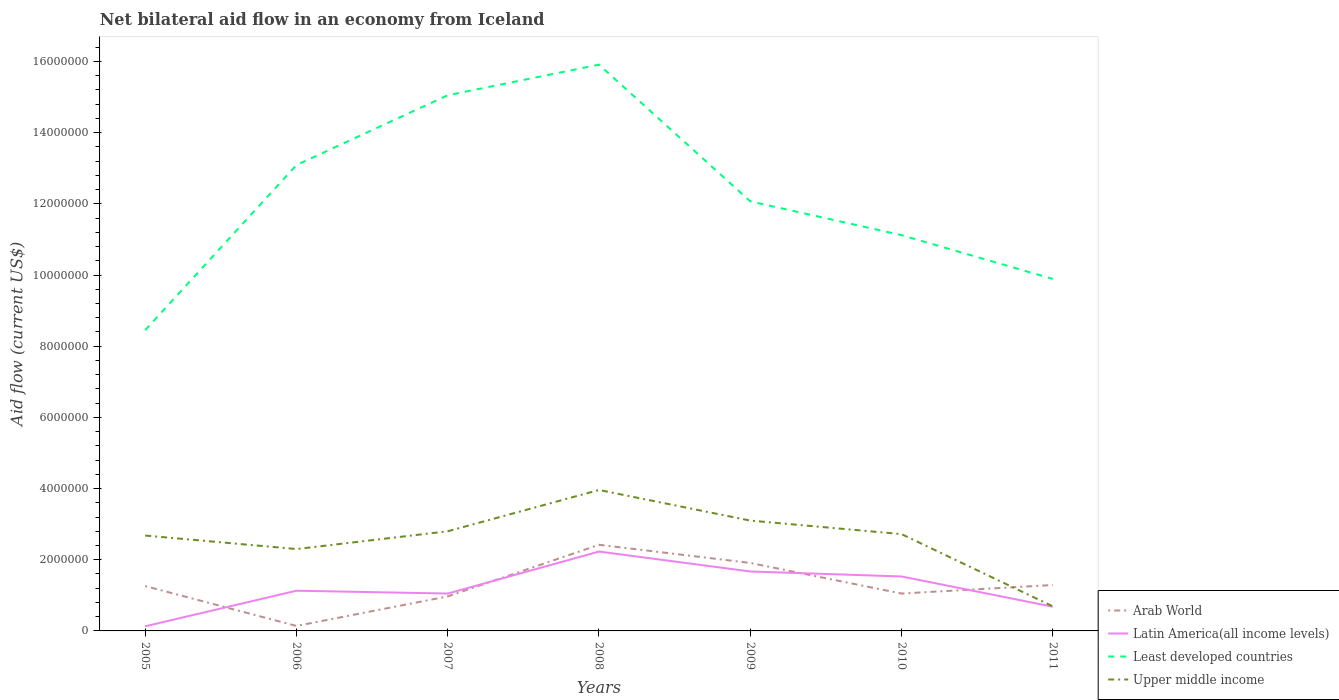Is the number of lines equal to the number of legend labels?
Offer a very short reply. Yes. Across all years, what is the maximum net bilateral aid flow in Least developed countries?
Offer a terse response. 8.45e+06. In which year was the net bilateral aid flow in Least developed countries maximum?
Your response must be concise. 2005. What is the total net bilateral aid flow in Least developed countries in the graph?
Your answer should be compact. -2.67e+06. What is the difference between the highest and the second highest net bilateral aid flow in Latin America(all income levels)?
Make the answer very short. 2.10e+06. What is the difference between the highest and the lowest net bilateral aid flow in Arab World?
Your response must be concise. 2. How many years are there in the graph?
Provide a short and direct response. 7. Where does the legend appear in the graph?
Give a very brief answer. Bottom right. What is the title of the graph?
Your answer should be very brief. Net bilateral aid flow in an economy from Iceland. What is the label or title of the X-axis?
Ensure brevity in your answer.  Years. What is the Aid flow (current US$) of Arab World in 2005?
Your response must be concise. 1.26e+06. What is the Aid flow (current US$) in Least developed countries in 2005?
Provide a short and direct response. 8.45e+06. What is the Aid flow (current US$) in Upper middle income in 2005?
Your answer should be very brief. 2.68e+06. What is the Aid flow (current US$) of Latin America(all income levels) in 2006?
Provide a short and direct response. 1.13e+06. What is the Aid flow (current US$) in Least developed countries in 2006?
Your response must be concise. 1.31e+07. What is the Aid flow (current US$) of Upper middle income in 2006?
Your answer should be very brief. 2.30e+06. What is the Aid flow (current US$) in Arab World in 2007?
Ensure brevity in your answer.  9.70e+05. What is the Aid flow (current US$) in Latin America(all income levels) in 2007?
Provide a succinct answer. 1.05e+06. What is the Aid flow (current US$) of Least developed countries in 2007?
Provide a short and direct response. 1.50e+07. What is the Aid flow (current US$) in Upper middle income in 2007?
Make the answer very short. 2.80e+06. What is the Aid flow (current US$) of Arab World in 2008?
Offer a very short reply. 2.42e+06. What is the Aid flow (current US$) of Latin America(all income levels) in 2008?
Make the answer very short. 2.23e+06. What is the Aid flow (current US$) of Least developed countries in 2008?
Ensure brevity in your answer.  1.59e+07. What is the Aid flow (current US$) in Upper middle income in 2008?
Your response must be concise. 3.96e+06. What is the Aid flow (current US$) of Arab World in 2009?
Your answer should be very brief. 1.91e+06. What is the Aid flow (current US$) of Latin America(all income levels) in 2009?
Your answer should be very brief. 1.67e+06. What is the Aid flow (current US$) in Least developed countries in 2009?
Make the answer very short. 1.21e+07. What is the Aid flow (current US$) of Upper middle income in 2009?
Your answer should be compact. 3.10e+06. What is the Aid flow (current US$) in Arab World in 2010?
Provide a short and direct response. 1.05e+06. What is the Aid flow (current US$) of Latin America(all income levels) in 2010?
Provide a short and direct response. 1.53e+06. What is the Aid flow (current US$) of Least developed countries in 2010?
Offer a terse response. 1.11e+07. What is the Aid flow (current US$) in Upper middle income in 2010?
Make the answer very short. 2.72e+06. What is the Aid flow (current US$) in Arab World in 2011?
Ensure brevity in your answer.  1.29e+06. What is the Aid flow (current US$) of Latin America(all income levels) in 2011?
Offer a terse response. 6.80e+05. What is the Aid flow (current US$) of Least developed countries in 2011?
Your answer should be very brief. 9.89e+06. What is the Aid flow (current US$) of Upper middle income in 2011?
Keep it short and to the point. 6.90e+05. Across all years, what is the maximum Aid flow (current US$) of Arab World?
Make the answer very short. 2.42e+06. Across all years, what is the maximum Aid flow (current US$) of Latin America(all income levels)?
Your response must be concise. 2.23e+06. Across all years, what is the maximum Aid flow (current US$) of Least developed countries?
Provide a short and direct response. 1.59e+07. Across all years, what is the maximum Aid flow (current US$) in Upper middle income?
Your answer should be compact. 3.96e+06. Across all years, what is the minimum Aid flow (current US$) in Arab World?
Your response must be concise. 1.40e+05. Across all years, what is the minimum Aid flow (current US$) in Latin America(all income levels)?
Give a very brief answer. 1.30e+05. Across all years, what is the minimum Aid flow (current US$) of Least developed countries?
Give a very brief answer. 8.45e+06. Across all years, what is the minimum Aid flow (current US$) in Upper middle income?
Keep it short and to the point. 6.90e+05. What is the total Aid flow (current US$) in Arab World in the graph?
Keep it short and to the point. 9.04e+06. What is the total Aid flow (current US$) of Latin America(all income levels) in the graph?
Provide a short and direct response. 8.42e+06. What is the total Aid flow (current US$) in Least developed countries in the graph?
Ensure brevity in your answer.  8.56e+07. What is the total Aid flow (current US$) in Upper middle income in the graph?
Make the answer very short. 1.82e+07. What is the difference between the Aid flow (current US$) in Arab World in 2005 and that in 2006?
Ensure brevity in your answer.  1.12e+06. What is the difference between the Aid flow (current US$) in Least developed countries in 2005 and that in 2006?
Offer a very short reply. -4.64e+06. What is the difference between the Aid flow (current US$) of Upper middle income in 2005 and that in 2006?
Keep it short and to the point. 3.80e+05. What is the difference between the Aid flow (current US$) in Latin America(all income levels) in 2005 and that in 2007?
Offer a very short reply. -9.20e+05. What is the difference between the Aid flow (current US$) of Least developed countries in 2005 and that in 2007?
Ensure brevity in your answer.  -6.60e+06. What is the difference between the Aid flow (current US$) in Arab World in 2005 and that in 2008?
Your response must be concise. -1.16e+06. What is the difference between the Aid flow (current US$) of Latin America(all income levels) in 2005 and that in 2008?
Give a very brief answer. -2.10e+06. What is the difference between the Aid flow (current US$) of Least developed countries in 2005 and that in 2008?
Your answer should be very brief. -7.46e+06. What is the difference between the Aid flow (current US$) of Upper middle income in 2005 and that in 2008?
Offer a very short reply. -1.28e+06. What is the difference between the Aid flow (current US$) of Arab World in 2005 and that in 2009?
Offer a very short reply. -6.50e+05. What is the difference between the Aid flow (current US$) of Latin America(all income levels) in 2005 and that in 2009?
Your answer should be compact. -1.54e+06. What is the difference between the Aid flow (current US$) of Least developed countries in 2005 and that in 2009?
Your answer should be compact. -3.62e+06. What is the difference between the Aid flow (current US$) of Upper middle income in 2005 and that in 2009?
Provide a short and direct response. -4.20e+05. What is the difference between the Aid flow (current US$) of Latin America(all income levels) in 2005 and that in 2010?
Keep it short and to the point. -1.40e+06. What is the difference between the Aid flow (current US$) of Least developed countries in 2005 and that in 2010?
Provide a succinct answer. -2.67e+06. What is the difference between the Aid flow (current US$) of Upper middle income in 2005 and that in 2010?
Make the answer very short. -4.00e+04. What is the difference between the Aid flow (current US$) in Latin America(all income levels) in 2005 and that in 2011?
Give a very brief answer. -5.50e+05. What is the difference between the Aid flow (current US$) in Least developed countries in 2005 and that in 2011?
Your response must be concise. -1.44e+06. What is the difference between the Aid flow (current US$) of Upper middle income in 2005 and that in 2011?
Make the answer very short. 1.99e+06. What is the difference between the Aid flow (current US$) of Arab World in 2006 and that in 2007?
Your answer should be very brief. -8.30e+05. What is the difference between the Aid flow (current US$) of Latin America(all income levels) in 2006 and that in 2007?
Offer a terse response. 8.00e+04. What is the difference between the Aid flow (current US$) of Least developed countries in 2006 and that in 2007?
Offer a very short reply. -1.96e+06. What is the difference between the Aid flow (current US$) of Upper middle income in 2006 and that in 2007?
Offer a terse response. -5.00e+05. What is the difference between the Aid flow (current US$) in Arab World in 2006 and that in 2008?
Provide a succinct answer. -2.28e+06. What is the difference between the Aid flow (current US$) in Latin America(all income levels) in 2006 and that in 2008?
Make the answer very short. -1.10e+06. What is the difference between the Aid flow (current US$) in Least developed countries in 2006 and that in 2008?
Provide a short and direct response. -2.82e+06. What is the difference between the Aid flow (current US$) in Upper middle income in 2006 and that in 2008?
Your response must be concise. -1.66e+06. What is the difference between the Aid flow (current US$) of Arab World in 2006 and that in 2009?
Your answer should be compact. -1.77e+06. What is the difference between the Aid flow (current US$) in Latin America(all income levels) in 2006 and that in 2009?
Make the answer very short. -5.40e+05. What is the difference between the Aid flow (current US$) in Least developed countries in 2006 and that in 2009?
Keep it short and to the point. 1.02e+06. What is the difference between the Aid flow (current US$) of Upper middle income in 2006 and that in 2009?
Provide a succinct answer. -8.00e+05. What is the difference between the Aid flow (current US$) in Arab World in 2006 and that in 2010?
Provide a succinct answer. -9.10e+05. What is the difference between the Aid flow (current US$) of Latin America(all income levels) in 2006 and that in 2010?
Offer a very short reply. -4.00e+05. What is the difference between the Aid flow (current US$) of Least developed countries in 2006 and that in 2010?
Offer a very short reply. 1.97e+06. What is the difference between the Aid flow (current US$) of Upper middle income in 2006 and that in 2010?
Provide a succinct answer. -4.20e+05. What is the difference between the Aid flow (current US$) of Arab World in 2006 and that in 2011?
Ensure brevity in your answer.  -1.15e+06. What is the difference between the Aid flow (current US$) in Least developed countries in 2006 and that in 2011?
Keep it short and to the point. 3.20e+06. What is the difference between the Aid flow (current US$) of Upper middle income in 2006 and that in 2011?
Your answer should be compact. 1.61e+06. What is the difference between the Aid flow (current US$) of Arab World in 2007 and that in 2008?
Keep it short and to the point. -1.45e+06. What is the difference between the Aid flow (current US$) of Latin America(all income levels) in 2007 and that in 2008?
Provide a short and direct response. -1.18e+06. What is the difference between the Aid flow (current US$) of Least developed countries in 2007 and that in 2008?
Offer a terse response. -8.60e+05. What is the difference between the Aid flow (current US$) in Upper middle income in 2007 and that in 2008?
Ensure brevity in your answer.  -1.16e+06. What is the difference between the Aid flow (current US$) in Arab World in 2007 and that in 2009?
Your response must be concise. -9.40e+05. What is the difference between the Aid flow (current US$) in Latin America(all income levels) in 2007 and that in 2009?
Ensure brevity in your answer.  -6.20e+05. What is the difference between the Aid flow (current US$) in Least developed countries in 2007 and that in 2009?
Offer a very short reply. 2.98e+06. What is the difference between the Aid flow (current US$) in Latin America(all income levels) in 2007 and that in 2010?
Keep it short and to the point. -4.80e+05. What is the difference between the Aid flow (current US$) in Least developed countries in 2007 and that in 2010?
Offer a very short reply. 3.93e+06. What is the difference between the Aid flow (current US$) of Arab World in 2007 and that in 2011?
Provide a succinct answer. -3.20e+05. What is the difference between the Aid flow (current US$) of Least developed countries in 2007 and that in 2011?
Keep it short and to the point. 5.16e+06. What is the difference between the Aid flow (current US$) of Upper middle income in 2007 and that in 2011?
Provide a short and direct response. 2.11e+06. What is the difference between the Aid flow (current US$) in Arab World in 2008 and that in 2009?
Provide a short and direct response. 5.10e+05. What is the difference between the Aid flow (current US$) in Latin America(all income levels) in 2008 and that in 2009?
Keep it short and to the point. 5.60e+05. What is the difference between the Aid flow (current US$) in Least developed countries in 2008 and that in 2009?
Offer a terse response. 3.84e+06. What is the difference between the Aid flow (current US$) of Upper middle income in 2008 and that in 2009?
Provide a succinct answer. 8.60e+05. What is the difference between the Aid flow (current US$) in Arab World in 2008 and that in 2010?
Your answer should be compact. 1.37e+06. What is the difference between the Aid flow (current US$) of Least developed countries in 2008 and that in 2010?
Make the answer very short. 4.79e+06. What is the difference between the Aid flow (current US$) of Upper middle income in 2008 and that in 2010?
Ensure brevity in your answer.  1.24e+06. What is the difference between the Aid flow (current US$) of Arab World in 2008 and that in 2011?
Your response must be concise. 1.13e+06. What is the difference between the Aid flow (current US$) in Latin America(all income levels) in 2008 and that in 2011?
Ensure brevity in your answer.  1.55e+06. What is the difference between the Aid flow (current US$) of Least developed countries in 2008 and that in 2011?
Your answer should be very brief. 6.02e+06. What is the difference between the Aid flow (current US$) in Upper middle income in 2008 and that in 2011?
Make the answer very short. 3.27e+06. What is the difference between the Aid flow (current US$) of Arab World in 2009 and that in 2010?
Ensure brevity in your answer.  8.60e+05. What is the difference between the Aid flow (current US$) of Least developed countries in 2009 and that in 2010?
Your response must be concise. 9.50e+05. What is the difference between the Aid flow (current US$) in Upper middle income in 2009 and that in 2010?
Give a very brief answer. 3.80e+05. What is the difference between the Aid flow (current US$) in Arab World in 2009 and that in 2011?
Provide a succinct answer. 6.20e+05. What is the difference between the Aid flow (current US$) of Latin America(all income levels) in 2009 and that in 2011?
Ensure brevity in your answer.  9.90e+05. What is the difference between the Aid flow (current US$) of Least developed countries in 2009 and that in 2011?
Offer a terse response. 2.18e+06. What is the difference between the Aid flow (current US$) of Upper middle income in 2009 and that in 2011?
Ensure brevity in your answer.  2.41e+06. What is the difference between the Aid flow (current US$) of Latin America(all income levels) in 2010 and that in 2011?
Ensure brevity in your answer.  8.50e+05. What is the difference between the Aid flow (current US$) in Least developed countries in 2010 and that in 2011?
Offer a very short reply. 1.23e+06. What is the difference between the Aid flow (current US$) in Upper middle income in 2010 and that in 2011?
Make the answer very short. 2.03e+06. What is the difference between the Aid flow (current US$) of Arab World in 2005 and the Aid flow (current US$) of Least developed countries in 2006?
Give a very brief answer. -1.18e+07. What is the difference between the Aid flow (current US$) in Arab World in 2005 and the Aid flow (current US$) in Upper middle income in 2006?
Your response must be concise. -1.04e+06. What is the difference between the Aid flow (current US$) of Latin America(all income levels) in 2005 and the Aid flow (current US$) of Least developed countries in 2006?
Your answer should be compact. -1.30e+07. What is the difference between the Aid flow (current US$) of Latin America(all income levels) in 2005 and the Aid flow (current US$) of Upper middle income in 2006?
Give a very brief answer. -2.17e+06. What is the difference between the Aid flow (current US$) of Least developed countries in 2005 and the Aid flow (current US$) of Upper middle income in 2006?
Ensure brevity in your answer.  6.15e+06. What is the difference between the Aid flow (current US$) of Arab World in 2005 and the Aid flow (current US$) of Latin America(all income levels) in 2007?
Your response must be concise. 2.10e+05. What is the difference between the Aid flow (current US$) of Arab World in 2005 and the Aid flow (current US$) of Least developed countries in 2007?
Offer a terse response. -1.38e+07. What is the difference between the Aid flow (current US$) in Arab World in 2005 and the Aid flow (current US$) in Upper middle income in 2007?
Provide a short and direct response. -1.54e+06. What is the difference between the Aid flow (current US$) of Latin America(all income levels) in 2005 and the Aid flow (current US$) of Least developed countries in 2007?
Your response must be concise. -1.49e+07. What is the difference between the Aid flow (current US$) in Latin America(all income levels) in 2005 and the Aid flow (current US$) in Upper middle income in 2007?
Provide a short and direct response. -2.67e+06. What is the difference between the Aid flow (current US$) of Least developed countries in 2005 and the Aid flow (current US$) of Upper middle income in 2007?
Make the answer very short. 5.65e+06. What is the difference between the Aid flow (current US$) in Arab World in 2005 and the Aid flow (current US$) in Latin America(all income levels) in 2008?
Your answer should be very brief. -9.70e+05. What is the difference between the Aid flow (current US$) in Arab World in 2005 and the Aid flow (current US$) in Least developed countries in 2008?
Your answer should be very brief. -1.46e+07. What is the difference between the Aid flow (current US$) of Arab World in 2005 and the Aid flow (current US$) of Upper middle income in 2008?
Your answer should be very brief. -2.70e+06. What is the difference between the Aid flow (current US$) in Latin America(all income levels) in 2005 and the Aid flow (current US$) in Least developed countries in 2008?
Make the answer very short. -1.58e+07. What is the difference between the Aid flow (current US$) of Latin America(all income levels) in 2005 and the Aid flow (current US$) of Upper middle income in 2008?
Your answer should be very brief. -3.83e+06. What is the difference between the Aid flow (current US$) of Least developed countries in 2005 and the Aid flow (current US$) of Upper middle income in 2008?
Your answer should be compact. 4.49e+06. What is the difference between the Aid flow (current US$) of Arab World in 2005 and the Aid flow (current US$) of Latin America(all income levels) in 2009?
Make the answer very short. -4.10e+05. What is the difference between the Aid flow (current US$) of Arab World in 2005 and the Aid flow (current US$) of Least developed countries in 2009?
Keep it short and to the point. -1.08e+07. What is the difference between the Aid flow (current US$) in Arab World in 2005 and the Aid flow (current US$) in Upper middle income in 2009?
Your answer should be very brief. -1.84e+06. What is the difference between the Aid flow (current US$) in Latin America(all income levels) in 2005 and the Aid flow (current US$) in Least developed countries in 2009?
Offer a terse response. -1.19e+07. What is the difference between the Aid flow (current US$) in Latin America(all income levels) in 2005 and the Aid flow (current US$) in Upper middle income in 2009?
Your answer should be compact. -2.97e+06. What is the difference between the Aid flow (current US$) in Least developed countries in 2005 and the Aid flow (current US$) in Upper middle income in 2009?
Offer a terse response. 5.35e+06. What is the difference between the Aid flow (current US$) of Arab World in 2005 and the Aid flow (current US$) of Latin America(all income levels) in 2010?
Provide a short and direct response. -2.70e+05. What is the difference between the Aid flow (current US$) in Arab World in 2005 and the Aid flow (current US$) in Least developed countries in 2010?
Your answer should be very brief. -9.86e+06. What is the difference between the Aid flow (current US$) in Arab World in 2005 and the Aid flow (current US$) in Upper middle income in 2010?
Your answer should be very brief. -1.46e+06. What is the difference between the Aid flow (current US$) in Latin America(all income levels) in 2005 and the Aid flow (current US$) in Least developed countries in 2010?
Offer a terse response. -1.10e+07. What is the difference between the Aid flow (current US$) of Latin America(all income levels) in 2005 and the Aid flow (current US$) of Upper middle income in 2010?
Offer a terse response. -2.59e+06. What is the difference between the Aid flow (current US$) of Least developed countries in 2005 and the Aid flow (current US$) of Upper middle income in 2010?
Ensure brevity in your answer.  5.73e+06. What is the difference between the Aid flow (current US$) of Arab World in 2005 and the Aid flow (current US$) of Latin America(all income levels) in 2011?
Your answer should be very brief. 5.80e+05. What is the difference between the Aid flow (current US$) in Arab World in 2005 and the Aid flow (current US$) in Least developed countries in 2011?
Offer a terse response. -8.63e+06. What is the difference between the Aid flow (current US$) of Arab World in 2005 and the Aid flow (current US$) of Upper middle income in 2011?
Your response must be concise. 5.70e+05. What is the difference between the Aid flow (current US$) of Latin America(all income levels) in 2005 and the Aid flow (current US$) of Least developed countries in 2011?
Make the answer very short. -9.76e+06. What is the difference between the Aid flow (current US$) in Latin America(all income levels) in 2005 and the Aid flow (current US$) in Upper middle income in 2011?
Offer a terse response. -5.60e+05. What is the difference between the Aid flow (current US$) in Least developed countries in 2005 and the Aid flow (current US$) in Upper middle income in 2011?
Provide a short and direct response. 7.76e+06. What is the difference between the Aid flow (current US$) in Arab World in 2006 and the Aid flow (current US$) in Latin America(all income levels) in 2007?
Make the answer very short. -9.10e+05. What is the difference between the Aid flow (current US$) in Arab World in 2006 and the Aid flow (current US$) in Least developed countries in 2007?
Provide a succinct answer. -1.49e+07. What is the difference between the Aid flow (current US$) of Arab World in 2006 and the Aid flow (current US$) of Upper middle income in 2007?
Offer a terse response. -2.66e+06. What is the difference between the Aid flow (current US$) in Latin America(all income levels) in 2006 and the Aid flow (current US$) in Least developed countries in 2007?
Ensure brevity in your answer.  -1.39e+07. What is the difference between the Aid flow (current US$) of Latin America(all income levels) in 2006 and the Aid flow (current US$) of Upper middle income in 2007?
Your response must be concise. -1.67e+06. What is the difference between the Aid flow (current US$) in Least developed countries in 2006 and the Aid flow (current US$) in Upper middle income in 2007?
Offer a very short reply. 1.03e+07. What is the difference between the Aid flow (current US$) in Arab World in 2006 and the Aid flow (current US$) in Latin America(all income levels) in 2008?
Your response must be concise. -2.09e+06. What is the difference between the Aid flow (current US$) of Arab World in 2006 and the Aid flow (current US$) of Least developed countries in 2008?
Make the answer very short. -1.58e+07. What is the difference between the Aid flow (current US$) in Arab World in 2006 and the Aid flow (current US$) in Upper middle income in 2008?
Provide a short and direct response. -3.82e+06. What is the difference between the Aid flow (current US$) of Latin America(all income levels) in 2006 and the Aid flow (current US$) of Least developed countries in 2008?
Ensure brevity in your answer.  -1.48e+07. What is the difference between the Aid flow (current US$) of Latin America(all income levels) in 2006 and the Aid flow (current US$) of Upper middle income in 2008?
Offer a very short reply. -2.83e+06. What is the difference between the Aid flow (current US$) of Least developed countries in 2006 and the Aid flow (current US$) of Upper middle income in 2008?
Your answer should be compact. 9.13e+06. What is the difference between the Aid flow (current US$) in Arab World in 2006 and the Aid flow (current US$) in Latin America(all income levels) in 2009?
Keep it short and to the point. -1.53e+06. What is the difference between the Aid flow (current US$) in Arab World in 2006 and the Aid flow (current US$) in Least developed countries in 2009?
Keep it short and to the point. -1.19e+07. What is the difference between the Aid flow (current US$) of Arab World in 2006 and the Aid flow (current US$) of Upper middle income in 2009?
Give a very brief answer. -2.96e+06. What is the difference between the Aid flow (current US$) in Latin America(all income levels) in 2006 and the Aid flow (current US$) in Least developed countries in 2009?
Provide a short and direct response. -1.09e+07. What is the difference between the Aid flow (current US$) of Latin America(all income levels) in 2006 and the Aid flow (current US$) of Upper middle income in 2009?
Offer a very short reply. -1.97e+06. What is the difference between the Aid flow (current US$) of Least developed countries in 2006 and the Aid flow (current US$) of Upper middle income in 2009?
Offer a very short reply. 9.99e+06. What is the difference between the Aid flow (current US$) of Arab World in 2006 and the Aid flow (current US$) of Latin America(all income levels) in 2010?
Your response must be concise. -1.39e+06. What is the difference between the Aid flow (current US$) of Arab World in 2006 and the Aid flow (current US$) of Least developed countries in 2010?
Make the answer very short. -1.10e+07. What is the difference between the Aid flow (current US$) in Arab World in 2006 and the Aid flow (current US$) in Upper middle income in 2010?
Provide a short and direct response. -2.58e+06. What is the difference between the Aid flow (current US$) of Latin America(all income levels) in 2006 and the Aid flow (current US$) of Least developed countries in 2010?
Provide a succinct answer. -9.99e+06. What is the difference between the Aid flow (current US$) of Latin America(all income levels) in 2006 and the Aid flow (current US$) of Upper middle income in 2010?
Your answer should be very brief. -1.59e+06. What is the difference between the Aid flow (current US$) in Least developed countries in 2006 and the Aid flow (current US$) in Upper middle income in 2010?
Your response must be concise. 1.04e+07. What is the difference between the Aid flow (current US$) in Arab World in 2006 and the Aid flow (current US$) in Latin America(all income levels) in 2011?
Your answer should be very brief. -5.40e+05. What is the difference between the Aid flow (current US$) in Arab World in 2006 and the Aid flow (current US$) in Least developed countries in 2011?
Offer a terse response. -9.75e+06. What is the difference between the Aid flow (current US$) in Arab World in 2006 and the Aid flow (current US$) in Upper middle income in 2011?
Make the answer very short. -5.50e+05. What is the difference between the Aid flow (current US$) in Latin America(all income levels) in 2006 and the Aid flow (current US$) in Least developed countries in 2011?
Keep it short and to the point. -8.76e+06. What is the difference between the Aid flow (current US$) of Least developed countries in 2006 and the Aid flow (current US$) of Upper middle income in 2011?
Offer a terse response. 1.24e+07. What is the difference between the Aid flow (current US$) in Arab World in 2007 and the Aid flow (current US$) in Latin America(all income levels) in 2008?
Your answer should be very brief. -1.26e+06. What is the difference between the Aid flow (current US$) in Arab World in 2007 and the Aid flow (current US$) in Least developed countries in 2008?
Your response must be concise. -1.49e+07. What is the difference between the Aid flow (current US$) of Arab World in 2007 and the Aid flow (current US$) of Upper middle income in 2008?
Provide a succinct answer. -2.99e+06. What is the difference between the Aid flow (current US$) of Latin America(all income levels) in 2007 and the Aid flow (current US$) of Least developed countries in 2008?
Offer a very short reply. -1.49e+07. What is the difference between the Aid flow (current US$) of Latin America(all income levels) in 2007 and the Aid flow (current US$) of Upper middle income in 2008?
Give a very brief answer. -2.91e+06. What is the difference between the Aid flow (current US$) in Least developed countries in 2007 and the Aid flow (current US$) in Upper middle income in 2008?
Keep it short and to the point. 1.11e+07. What is the difference between the Aid flow (current US$) in Arab World in 2007 and the Aid flow (current US$) in Latin America(all income levels) in 2009?
Your response must be concise. -7.00e+05. What is the difference between the Aid flow (current US$) of Arab World in 2007 and the Aid flow (current US$) of Least developed countries in 2009?
Provide a succinct answer. -1.11e+07. What is the difference between the Aid flow (current US$) in Arab World in 2007 and the Aid flow (current US$) in Upper middle income in 2009?
Your answer should be very brief. -2.13e+06. What is the difference between the Aid flow (current US$) in Latin America(all income levels) in 2007 and the Aid flow (current US$) in Least developed countries in 2009?
Keep it short and to the point. -1.10e+07. What is the difference between the Aid flow (current US$) in Latin America(all income levels) in 2007 and the Aid flow (current US$) in Upper middle income in 2009?
Your answer should be very brief. -2.05e+06. What is the difference between the Aid flow (current US$) in Least developed countries in 2007 and the Aid flow (current US$) in Upper middle income in 2009?
Your answer should be compact. 1.20e+07. What is the difference between the Aid flow (current US$) of Arab World in 2007 and the Aid flow (current US$) of Latin America(all income levels) in 2010?
Provide a succinct answer. -5.60e+05. What is the difference between the Aid flow (current US$) of Arab World in 2007 and the Aid flow (current US$) of Least developed countries in 2010?
Ensure brevity in your answer.  -1.02e+07. What is the difference between the Aid flow (current US$) in Arab World in 2007 and the Aid flow (current US$) in Upper middle income in 2010?
Keep it short and to the point. -1.75e+06. What is the difference between the Aid flow (current US$) of Latin America(all income levels) in 2007 and the Aid flow (current US$) of Least developed countries in 2010?
Provide a succinct answer. -1.01e+07. What is the difference between the Aid flow (current US$) of Latin America(all income levels) in 2007 and the Aid flow (current US$) of Upper middle income in 2010?
Your answer should be very brief. -1.67e+06. What is the difference between the Aid flow (current US$) in Least developed countries in 2007 and the Aid flow (current US$) in Upper middle income in 2010?
Provide a succinct answer. 1.23e+07. What is the difference between the Aid flow (current US$) in Arab World in 2007 and the Aid flow (current US$) in Least developed countries in 2011?
Ensure brevity in your answer.  -8.92e+06. What is the difference between the Aid flow (current US$) in Latin America(all income levels) in 2007 and the Aid flow (current US$) in Least developed countries in 2011?
Give a very brief answer. -8.84e+06. What is the difference between the Aid flow (current US$) in Latin America(all income levels) in 2007 and the Aid flow (current US$) in Upper middle income in 2011?
Make the answer very short. 3.60e+05. What is the difference between the Aid flow (current US$) in Least developed countries in 2007 and the Aid flow (current US$) in Upper middle income in 2011?
Your answer should be very brief. 1.44e+07. What is the difference between the Aid flow (current US$) in Arab World in 2008 and the Aid flow (current US$) in Latin America(all income levels) in 2009?
Offer a terse response. 7.50e+05. What is the difference between the Aid flow (current US$) in Arab World in 2008 and the Aid flow (current US$) in Least developed countries in 2009?
Your answer should be very brief. -9.65e+06. What is the difference between the Aid flow (current US$) of Arab World in 2008 and the Aid flow (current US$) of Upper middle income in 2009?
Provide a succinct answer. -6.80e+05. What is the difference between the Aid flow (current US$) of Latin America(all income levels) in 2008 and the Aid flow (current US$) of Least developed countries in 2009?
Offer a very short reply. -9.84e+06. What is the difference between the Aid flow (current US$) of Latin America(all income levels) in 2008 and the Aid flow (current US$) of Upper middle income in 2009?
Provide a short and direct response. -8.70e+05. What is the difference between the Aid flow (current US$) in Least developed countries in 2008 and the Aid flow (current US$) in Upper middle income in 2009?
Give a very brief answer. 1.28e+07. What is the difference between the Aid flow (current US$) of Arab World in 2008 and the Aid flow (current US$) of Latin America(all income levels) in 2010?
Provide a succinct answer. 8.90e+05. What is the difference between the Aid flow (current US$) of Arab World in 2008 and the Aid flow (current US$) of Least developed countries in 2010?
Provide a short and direct response. -8.70e+06. What is the difference between the Aid flow (current US$) of Latin America(all income levels) in 2008 and the Aid flow (current US$) of Least developed countries in 2010?
Make the answer very short. -8.89e+06. What is the difference between the Aid flow (current US$) of Latin America(all income levels) in 2008 and the Aid flow (current US$) of Upper middle income in 2010?
Give a very brief answer. -4.90e+05. What is the difference between the Aid flow (current US$) of Least developed countries in 2008 and the Aid flow (current US$) of Upper middle income in 2010?
Make the answer very short. 1.32e+07. What is the difference between the Aid flow (current US$) in Arab World in 2008 and the Aid flow (current US$) in Latin America(all income levels) in 2011?
Your response must be concise. 1.74e+06. What is the difference between the Aid flow (current US$) of Arab World in 2008 and the Aid flow (current US$) of Least developed countries in 2011?
Ensure brevity in your answer.  -7.47e+06. What is the difference between the Aid flow (current US$) in Arab World in 2008 and the Aid flow (current US$) in Upper middle income in 2011?
Offer a terse response. 1.73e+06. What is the difference between the Aid flow (current US$) in Latin America(all income levels) in 2008 and the Aid flow (current US$) in Least developed countries in 2011?
Offer a terse response. -7.66e+06. What is the difference between the Aid flow (current US$) in Latin America(all income levels) in 2008 and the Aid flow (current US$) in Upper middle income in 2011?
Your response must be concise. 1.54e+06. What is the difference between the Aid flow (current US$) in Least developed countries in 2008 and the Aid flow (current US$) in Upper middle income in 2011?
Your answer should be compact. 1.52e+07. What is the difference between the Aid flow (current US$) in Arab World in 2009 and the Aid flow (current US$) in Latin America(all income levels) in 2010?
Your answer should be very brief. 3.80e+05. What is the difference between the Aid flow (current US$) of Arab World in 2009 and the Aid flow (current US$) of Least developed countries in 2010?
Provide a short and direct response. -9.21e+06. What is the difference between the Aid flow (current US$) in Arab World in 2009 and the Aid flow (current US$) in Upper middle income in 2010?
Your answer should be compact. -8.10e+05. What is the difference between the Aid flow (current US$) of Latin America(all income levels) in 2009 and the Aid flow (current US$) of Least developed countries in 2010?
Keep it short and to the point. -9.45e+06. What is the difference between the Aid flow (current US$) in Latin America(all income levels) in 2009 and the Aid flow (current US$) in Upper middle income in 2010?
Provide a short and direct response. -1.05e+06. What is the difference between the Aid flow (current US$) of Least developed countries in 2009 and the Aid flow (current US$) of Upper middle income in 2010?
Your response must be concise. 9.35e+06. What is the difference between the Aid flow (current US$) of Arab World in 2009 and the Aid flow (current US$) of Latin America(all income levels) in 2011?
Provide a succinct answer. 1.23e+06. What is the difference between the Aid flow (current US$) of Arab World in 2009 and the Aid flow (current US$) of Least developed countries in 2011?
Your answer should be very brief. -7.98e+06. What is the difference between the Aid flow (current US$) of Arab World in 2009 and the Aid flow (current US$) of Upper middle income in 2011?
Provide a succinct answer. 1.22e+06. What is the difference between the Aid flow (current US$) in Latin America(all income levels) in 2009 and the Aid flow (current US$) in Least developed countries in 2011?
Keep it short and to the point. -8.22e+06. What is the difference between the Aid flow (current US$) in Latin America(all income levels) in 2009 and the Aid flow (current US$) in Upper middle income in 2011?
Your answer should be compact. 9.80e+05. What is the difference between the Aid flow (current US$) of Least developed countries in 2009 and the Aid flow (current US$) of Upper middle income in 2011?
Offer a terse response. 1.14e+07. What is the difference between the Aid flow (current US$) in Arab World in 2010 and the Aid flow (current US$) in Latin America(all income levels) in 2011?
Ensure brevity in your answer.  3.70e+05. What is the difference between the Aid flow (current US$) of Arab World in 2010 and the Aid flow (current US$) of Least developed countries in 2011?
Provide a short and direct response. -8.84e+06. What is the difference between the Aid flow (current US$) in Arab World in 2010 and the Aid flow (current US$) in Upper middle income in 2011?
Keep it short and to the point. 3.60e+05. What is the difference between the Aid flow (current US$) of Latin America(all income levels) in 2010 and the Aid flow (current US$) of Least developed countries in 2011?
Provide a succinct answer. -8.36e+06. What is the difference between the Aid flow (current US$) of Latin America(all income levels) in 2010 and the Aid flow (current US$) of Upper middle income in 2011?
Your answer should be very brief. 8.40e+05. What is the difference between the Aid flow (current US$) in Least developed countries in 2010 and the Aid flow (current US$) in Upper middle income in 2011?
Offer a very short reply. 1.04e+07. What is the average Aid flow (current US$) in Arab World per year?
Your answer should be compact. 1.29e+06. What is the average Aid flow (current US$) in Latin America(all income levels) per year?
Offer a very short reply. 1.20e+06. What is the average Aid flow (current US$) of Least developed countries per year?
Ensure brevity in your answer.  1.22e+07. What is the average Aid flow (current US$) of Upper middle income per year?
Make the answer very short. 2.61e+06. In the year 2005, what is the difference between the Aid flow (current US$) of Arab World and Aid flow (current US$) of Latin America(all income levels)?
Your answer should be very brief. 1.13e+06. In the year 2005, what is the difference between the Aid flow (current US$) in Arab World and Aid flow (current US$) in Least developed countries?
Offer a terse response. -7.19e+06. In the year 2005, what is the difference between the Aid flow (current US$) in Arab World and Aid flow (current US$) in Upper middle income?
Your answer should be very brief. -1.42e+06. In the year 2005, what is the difference between the Aid flow (current US$) of Latin America(all income levels) and Aid flow (current US$) of Least developed countries?
Keep it short and to the point. -8.32e+06. In the year 2005, what is the difference between the Aid flow (current US$) in Latin America(all income levels) and Aid flow (current US$) in Upper middle income?
Ensure brevity in your answer.  -2.55e+06. In the year 2005, what is the difference between the Aid flow (current US$) of Least developed countries and Aid flow (current US$) of Upper middle income?
Offer a very short reply. 5.77e+06. In the year 2006, what is the difference between the Aid flow (current US$) in Arab World and Aid flow (current US$) in Latin America(all income levels)?
Offer a terse response. -9.90e+05. In the year 2006, what is the difference between the Aid flow (current US$) in Arab World and Aid flow (current US$) in Least developed countries?
Provide a short and direct response. -1.30e+07. In the year 2006, what is the difference between the Aid flow (current US$) in Arab World and Aid flow (current US$) in Upper middle income?
Offer a very short reply. -2.16e+06. In the year 2006, what is the difference between the Aid flow (current US$) in Latin America(all income levels) and Aid flow (current US$) in Least developed countries?
Make the answer very short. -1.20e+07. In the year 2006, what is the difference between the Aid flow (current US$) of Latin America(all income levels) and Aid flow (current US$) of Upper middle income?
Offer a very short reply. -1.17e+06. In the year 2006, what is the difference between the Aid flow (current US$) of Least developed countries and Aid flow (current US$) of Upper middle income?
Your response must be concise. 1.08e+07. In the year 2007, what is the difference between the Aid flow (current US$) in Arab World and Aid flow (current US$) in Least developed countries?
Offer a terse response. -1.41e+07. In the year 2007, what is the difference between the Aid flow (current US$) of Arab World and Aid flow (current US$) of Upper middle income?
Provide a succinct answer. -1.83e+06. In the year 2007, what is the difference between the Aid flow (current US$) in Latin America(all income levels) and Aid flow (current US$) in Least developed countries?
Your answer should be compact. -1.40e+07. In the year 2007, what is the difference between the Aid flow (current US$) of Latin America(all income levels) and Aid flow (current US$) of Upper middle income?
Your answer should be compact. -1.75e+06. In the year 2007, what is the difference between the Aid flow (current US$) in Least developed countries and Aid flow (current US$) in Upper middle income?
Give a very brief answer. 1.22e+07. In the year 2008, what is the difference between the Aid flow (current US$) of Arab World and Aid flow (current US$) of Latin America(all income levels)?
Your response must be concise. 1.90e+05. In the year 2008, what is the difference between the Aid flow (current US$) in Arab World and Aid flow (current US$) in Least developed countries?
Offer a terse response. -1.35e+07. In the year 2008, what is the difference between the Aid flow (current US$) in Arab World and Aid flow (current US$) in Upper middle income?
Offer a very short reply. -1.54e+06. In the year 2008, what is the difference between the Aid flow (current US$) in Latin America(all income levels) and Aid flow (current US$) in Least developed countries?
Provide a succinct answer. -1.37e+07. In the year 2008, what is the difference between the Aid flow (current US$) of Latin America(all income levels) and Aid flow (current US$) of Upper middle income?
Give a very brief answer. -1.73e+06. In the year 2008, what is the difference between the Aid flow (current US$) in Least developed countries and Aid flow (current US$) in Upper middle income?
Offer a very short reply. 1.20e+07. In the year 2009, what is the difference between the Aid flow (current US$) of Arab World and Aid flow (current US$) of Least developed countries?
Give a very brief answer. -1.02e+07. In the year 2009, what is the difference between the Aid flow (current US$) of Arab World and Aid flow (current US$) of Upper middle income?
Provide a succinct answer. -1.19e+06. In the year 2009, what is the difference between the Aid flow (current US$) in Latin America(all income levels) and Aid flow (current US$) in Least developed countries?
Keep it short and to the point. -1.04e+07. In the year 2009, what is the difference between the Aid flow (current US$) in Latin America(all income levels) and Aid flow (current US$) in Upper middle income?
Your answer should be very brief. -1.43e+06. In the year 2009, what is the difference between the Aid flow (current US$) in Least developed countries and Aid flow (current US$) in Upper middle income?
Give a very brief answer. 8.97e+06. In the year 2010, what is the difference between the Aid flow (current US$) of Arab World and Aid flow (current US$) of Latin America(all income levels)?
Ensure brevity in your answer.  -4.80e+05. In the year 2010, what is the difference between the Aid flow (current US$) of Arab World and Aid flow (current US$) of Least developed countries?
Provide a short and direct response. -1.01e+07. In the year 2010, what is the difference between the Aid flow (current US$) in Arab World and Aid flow (current US$) in Upper middle income?
Your answer should be compact. -1.67e+06. In the year 2010, what is the difference between the Aid flow (current US$) of Latin America(all income levels) and Aid flow (current US$) of Least developed countries?
Your response must be concise. -9.59e+06. In the year 2010, what is the difference between the Aid flow (current US$) of Latin America(all income levels) and Aid flow (current US$) of Upper middle income?
Your answer should be very brief. -1.19e+06. In the year 2010, what is the difference between the Aid flow (current US$) in Least developed countries and Aid flow (current US$) in Upper middle income?
Your answer should be compact. 8.40e+06. In the year 2011, what is the difference between the Aid flow (current US$) in Arab World and Aid flow (current US$) in Latin America(all income levels)?
Offer a very short reply. 6.10e+05. In the year 2011, what is the difference between the Aid flow (current US$) of Arab World and Aid flow (current US$) of Least developed countries?
Provide a succinct answer. -8.60e+06. In the year 2011, what is the difference between the Aid flow (current US$) of Latin America(all income levels) and Aid flow (current US$) of Least developed countries?
Offer a very short reply. -9.21e+06. In the year 2011, what is the difference between the Aid flow (current US$) in Least developed countries and Aid flow (current US$) in Upper middle income?
Your response must be concise. 9.20e+06. What is the ratio of the Aid flow (current US$) in Arab World in 2005 to that in 2006?
Keep it short and to the point. 9. What is the ratio of the Aid flow (current US$) in Latin America(all income levels) in 2005 to that in 2006?
Offer a terse response. 0.12. What is the ratio of the Aid flow (current US$) of Least developed countries in 2005 to that in 2006?
Ensure brevity in your answer.  0.65. What is the ratio of the Aid flow (current US$) in Upper middle income in 2005 to that in 2006?
Ensure brevity in your answer.  1.17. What is the ratio of the Aid flow (current US$) of Arab World in 2005 to that in 2007?
Give a very brief answer. 1.3. What is the ratio of the Aid flow (current US$) of Latin America(all income levels) in 2005 to that in 2007?
Your answer should be very brief. 0.12. What is the ratio of the Aid flow (current US$) of Least developed countries in 2005 to that in 2007?
Ensure brevity in your answer.  0.56. What is the ratio of the Aid flow (current US$) in Upper middle income in 2005 to that in 2007?
Make the answer very short. 0.96. What is the ratio of the Aid flow (current US$) in Arab World in 2005 to that in 2008?
Provide a short and direct response. 0.52. What is the ratio of the Aid flow (current US$) of Latin America(all income levels) in 2005 to that in 2008?
Provide a short and direct response. 0.06. What is the ratio of the Aid flow (current US$) of Least developed countries in 2005 to that in 2008?
Make the answer very short. 0.53. What is the ratio of the Aid flow (current US$) of Upper middle income in 2005 to that in 2008?
Offer a terse response. 0.68. What is the ratio of the Aid flow (current US$) of Arab World in 2005 to that in 2009?
Give a very brief answer. 0.66. What is the ratio of the Aid flow (current US$) in Latin America(all income levels) in 2005 to that in 2009?
Your answer should be very brief. 0.08. What is the ratio of the Aid flow (current US$) of Least developed countries in 2005 to that in 2009?
Provide a short and direct response. 0.7. What is the ratio of the Aid flow (current US$) of Upper middle income in 2005 to that in 2009?
Make the answer very short. 0.86. What is the ratio of the Aid flow (current US$) in Latin America(all income levels) in 2005 to that in 2010?
Your response must be concise. 0.09. What is the ratio of the Aid flow (current US$) of Least developed countries in 2005 to that in 2010?
Provide a succinct answer. 0.76. What is the ratio of the Aid flow (current US$) of Upper middle income in 2005 to that in 2010?
Offer a very short reply. 0.99. What is the ratio of the Aid flow (current US$) in Arab World in 2005 to that in 2011?
Your answer should be compact. 0.98. What is the ratio of the Aid flow (current US$) in Latin America(all income levels) in 2005 to that in 2011?
Your answer should be compact. 0.19. What is the ratio of the Aid flow (current US$) of Least developed countries in 2005 to that in 2011?
Ensure brevity in your answer.  0.85. What is the ratio of the Aid flow (current US$) of Upper middle income in 2005 to that in 2011?
Provide a succinct answer. 3.88. What is the ratio of the Aid flow (current US$) of Arab World in 2006 to that in 2007?
Ensure brevity in your answer.  0.14. What is the ratio of the Aid flow (current US$) in Latin America(all income levels) in 2006 to that in 2007?
Your answer should be compact. 1.08. What is the ratio of the Aid flow (current US$) in Least developed countries in 2006 to that in 2007?
Your answer should be compact. 0.87. What is the ratio of the Aid flow (current US$) in Upper middle income in 2006 to that in 2007?
Keep it short and to the point. 0.82. What is the ratio of the Aid flow (current US$) in Arab World in 2006 to that in 2008?
Keep it short and to the point. 0.06. What is the ratio of the Aid flow (current US$) of Latin America(all income levels) in 2006 to that in 2008?
Provide a short and direct response. 0.51. What is the ratio of the Aid flow (current US$) of Least developed countries in 2006 to that in 2008?
Make the answer very short. 0.82. What is the ratio of the Aid flow (current US$) of Upper middle income in 2006 to that in 2008?
Offer a terse response. 0.58. What is the ratio of the Aid flow (current US$) of Arab World in 2006 to that in 2009?
Your answer should be very brief. 0.07. What is the ratio of the Aid flow (current US$) of Latin America(all income levels) in 2006 to that in 2009?
Your answer should be very brief. 0.68. What is the ratio of the Aid flow (current US$) in Least developed countries in 2006 to that in 2009?
Offer a terse response. 1.08. What is the ratio of the Aid flow (current US$) in Upper middle income in 2006 to that in 2009?
Give a very brief answer. 0.74. What is the ratio of the Aid flow (current US$) in Arab World in 2006 to that in 2010?
Offer a terse response. 0.13. What is the ratio of the Aid flow (current US$) of Latin America(all income levels) in 2006 to that in 2010?
Give a very brief answer. 0.74. What is the ratio of the Aid flow (current US$) of Least developed countries in 2006 to that in 2010?
Ensure brevity in your answer.  1.18. What is the ratio of the Aid flow (current US$) of Upper middle income in 2006 to that in 2010?
Ensure brevity in your answer.  0.85. What is the ratio of the Aid flow (current US$) in Arab World in 2006 to that in 2011?
Your answer should be very brief. 0.11. What is the ratio of the Aid flow (current US$) of Latin America(all income levels) in 2006 to that in 2011?
Give a very brief answer. 1.66. What is the ratio of the Aid flow (current US$) of Least developed countries in 2006 to that in 2011?
Keep it short and to the point. 1.32. What is the ratio of the Aid flow (current US$) of Arab World in 2007 to that in 2008?
Make the answer very short. 0.4. What is the ratio of the Aid flow (current US$) in Latin America(all income levels) in 2007 to that in 2008?
Provide a short and direct response. 0.47. What is the ratio of the Aid flow (current US$) in Least developed countries in 2007 to that in 2008?
Offer a very short reply. 0.95. What is the ratio of the Aid flow (current US$) of Upper middle income in 2007 to that in 2008?
Ensure brevity in your answer.  0.71. What is the ratio of the Aid flow (current US$) in Arab World in 2007 to that in 2009?
Make the answer very short. 0.51. What is the ratio of the Aid flow (current US$) in Latin America(all income levels) in 2007 to that in 2009?
Provide a succinct answer. 0.63. What is the ratio of the Aid flow (current US$) of Least developed countries in 2007 to that in 2009?
Keep it short and to the point. 1.25. What is the ratio of the Aid flow (current US$) of Upper middle income in 2007 to that in 2009?
Offer a terse response. 0.9. What is the ratio of the Aid flow (current US$) of Arab World in 2007 to that in 2010?
Provide a succinct answer. 0.92. What is the ratio of the Aid flow (current US$) in Latin America(all income levels) in 2007 to that in 2010?
Your answer should be very brief. 0.69. What is the ratio of the Aid flow (current US$) in Least developed countries in 2007 to that in 2010?
Give a very brief answer. 1.35. What is the ratio of the Aid flow (current US$) of Upper middle income in 2007 to that in 2010?
Make the answer very short. 1.03. What is the ratio of the Aid flow (current US$) of Arab World in 2007 to that in 2011?
Provide a short and direct response. 0.75. What is the ratio of the Aid flow (current US$) of Latin America(all income levels) in 2007 to that in 2011?
Provide a short and direct response. 1.54. What is the ratio of the Aid flow (current US$) in Least developed countries in 2007 to that in 2011?
Make the answer very short. 1.52. What is the ratio of the Aid flow (current US$) of Upper middle income in 2007 to that in 2011?
Keep it short and to the point. 4.06. What is the ratio of the Aid flow (current US$) in Arab World in 2008 to that in 2009?
Give a very brief answer. 1.27. What is the ratio of the Aid flow (current US$) in Latin America(all income levels) in 2008 to that in 2009?
Keep it short and to the point. 1.34. What is the ratio of the Aid flow (current US$) of Least developed countries in 2008 to that in 2009?
Offer a very short reply. 1.32. What is the ratio of the Aid flow (current US$) in Upper middle income in 2008 to that in 2009?
Offer a very short reply. 1.28. What is the ratio of the Aid flow (current US$) of Arab World in 2008 to that in 2010?
Offer a terse response. 2.3. What is the ratio of the Aid flow (current US$) of Latin America(all income levels) in 2008 to that in 2010?
Your answer should be very brief. 1.46. What is the ratio of the Aid flow (current US$) in Least developed countries in 2008 to that in 2010?
Your response must be concise. 1.43. What is the ratio of the Aid flow (current US$) in Upper middle income in 2008 to that in 2010?
Your answer should be very brief. 1.46. What is the ratio of the Aid flow (current US$) of Arab World in 2008 to that in 2011?
Your answer should be very brief. 1.88. What is the ratio of the Aid flow (current US$) of Latin America(all income levels) in 2008 to that in 2011?
Make the answer very short. 3.28. What is the ratio of the Aid flow (current US$) of Least developed countries in 2008 to that in 2011?
Offer a terse response. 1.61. What is the ratio of the Aid flow (current US$) of Upper middle income in 2008 to that in 2011?
Offer a very short reply. 5.74. What is the ratio of the Aid flow (current US$) of Arab World in 2009 to that in 2010?
Your response must be concise. 1.82. What is the ratio of the Aid flow (current US$) of Latin America(all income levels) in 2009 to that in 2010?
Provide a short and direct response. 1.09. What is the ratio of the Aid flow (current US$) of Least developed countries in 2009 to that in 2010?
Your answer should be very brief. 1.09. What is the ratio of the Aid flow (current US$) of Upper middle income in 2009 to that in 2010?
Provide a short and direct response. 1.14. What is the ratio of the Aid flow (current US$) of Arab World in 2009 to that in 2011?
Your answer should be compact. 1.48. What is the ratio of the Aid flow (current US$) of Latin America(all income levels) in 2009 to that in 2011?
Give a very brief answer. 2.46. What is the ratio of the Aid flow (current US$) in Least developed countries in 2009 to that in 2011?
Keep it short and to the point. 1.22. What is the ratio of the Aid flow (current US$) in Upper middle income in 2009 to that in 2011?
Provide a succinct answer. 4.49. What is the ratio of the Aid flow (current US$) of Arab World in 2010 to that in 2011?
Provide a succinct answer. 0.81. What is the ratio of the Aid flow (current US$) in Latin America(all income levels) in 2010 to that in 2011?
Ensure brevity in your answer.  2.25. What is the ratio of the Aid flow (current US$) of Least developed countries in 2010 to that in 2011?
Keep it short and to the point. 1.12. What is the ratio of the Aid flow (current US$) in Upper middle income in 2010 to that in 2011?
Ensure brevity in your answer.  3.94. What is the difference between the highest and the second highest Aid flow (current US$) in Arab World?
Your answer should be compact. 5.10e+05. What is the difference between the highest and the second highest Aid flow (current US$) of Latin America(all income levels)?
Your answer should be compact. 5.60e+05. What is the difference between the highest and the second highest Aid flow (current US$) in Least developed countries?
Your answer should be compact. 8.60e+05. What is the difference between the highest and the second highest Aid flow (current US$) of Upper middle income?
Offer a very short reply. 8.60e+05. What is the difference between the highest and the lowest Aid flow (current US$) in Arab World?
Provide a succinct answer. 2.28e+06. What is the difference between the highest and the lowest Aid flow (current US$) in Latin America(all income levels)?
Provide a short and direct response. 2.10e+06. What is the difference between the highest and the lowest Aid flow (current US$) in Least developed countries?
Make the answer very short. 7.46e+06. What is the difference between the highest and the lowest Aid flow (current US$) of Upper middle income?
Your answer should be compact. 3.27e+06. 